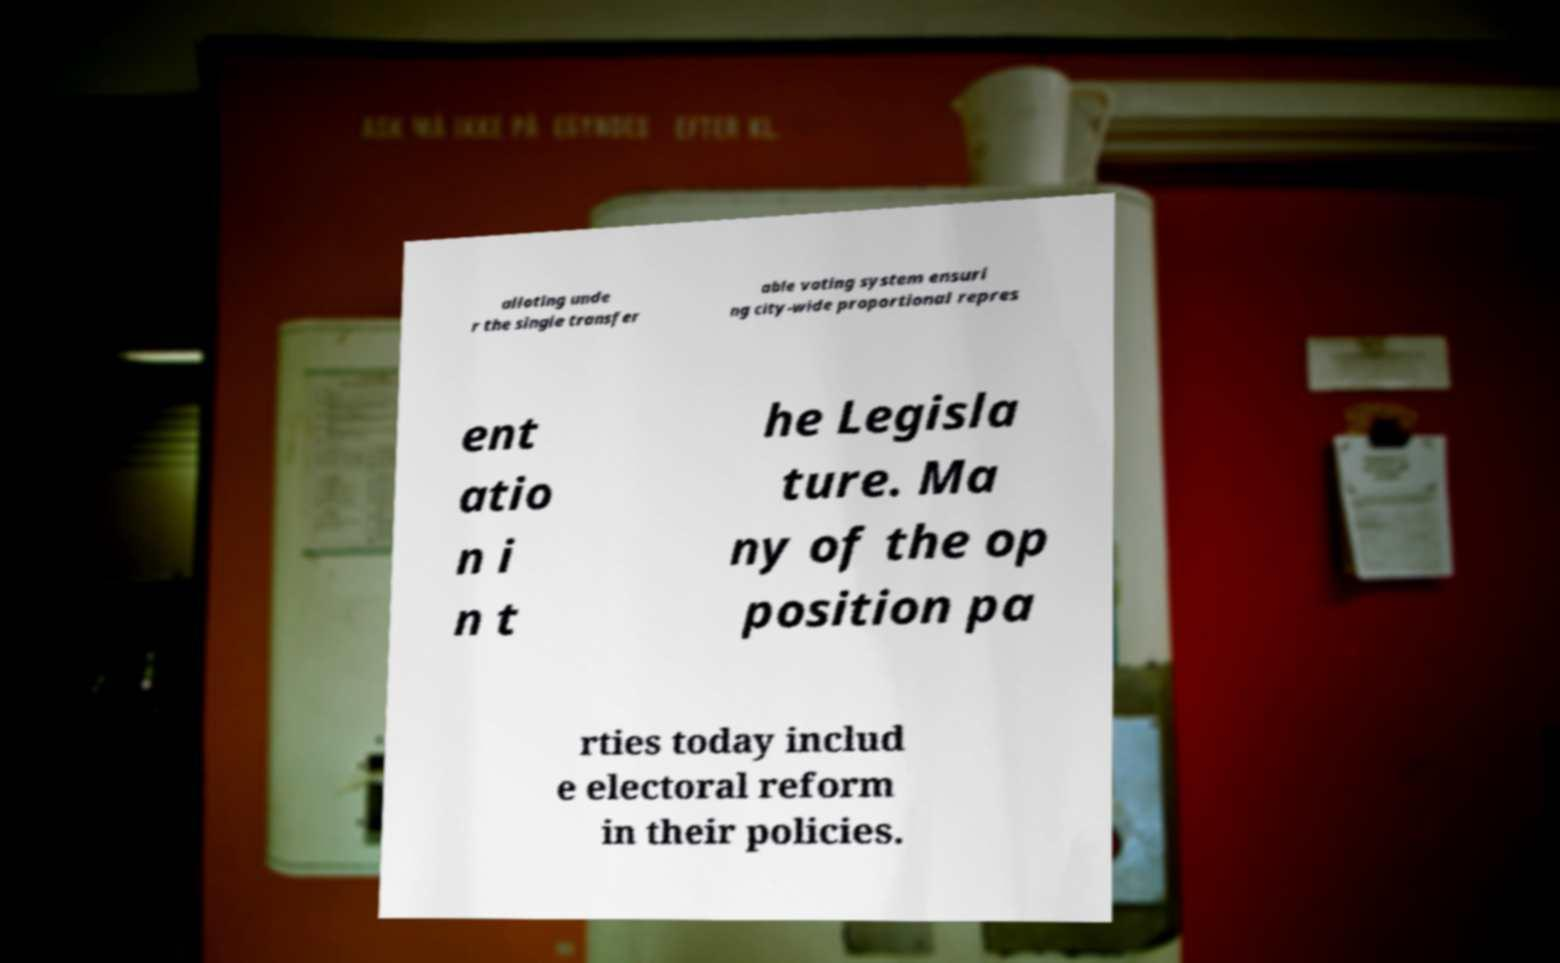Could you assist in decoding the text presented in this image and type it out clearly? alloting unde r the single transfer able voting system ensuri ng city-wide proportional repres ent atio n i n t he Legisla ture. Ma ny of the op position pa rties today includ e electoral reform in their policies. 